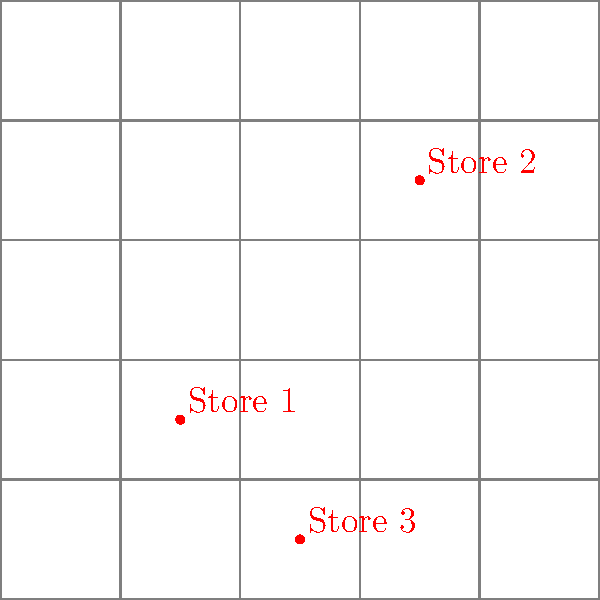Based on the street map provided, which potential store location has the highest parking availability within a 20-meter radius? Consider the size and proximity of nearby parking areas. To determine which potential store location has the highest parking availability within a 20-meter radius, we need to analyze each location:

1. Store 1 (30,30):
   - Located near parking area P1
   - P1 is approximately 20m x 20m in size
   - The store is right at the corner of P1, so the entire parking area is within 20m

2. Store 2 (70,70):
   - Located near parking area P2
   - P2 is approximately 20m x 20m in size
   - The store is about 10m away from P2, so the entire parking area is within 20m

3. Store 3 (50,10):
   - Located near parking area P3
   - P3 is approximately 20m x 20m in size
   - The store is about 10m away from P3, so the entire parking area is within 20m

All three stores have similar parking availability in terms of size. However, Store 1 has a slight advantage because:
- It's located right at the corner of its nearest parking area (P1)
- This proximity allows for easier access and visibility for potential customers
- The entire parking area is within the 20m radius, maximizing the available spaces

While Stores 2 and 3 also have good parking availability, they are slightly farther from their respective parking areas, which may impact convenience for customers.
Answer: Store 1 (30,30) 